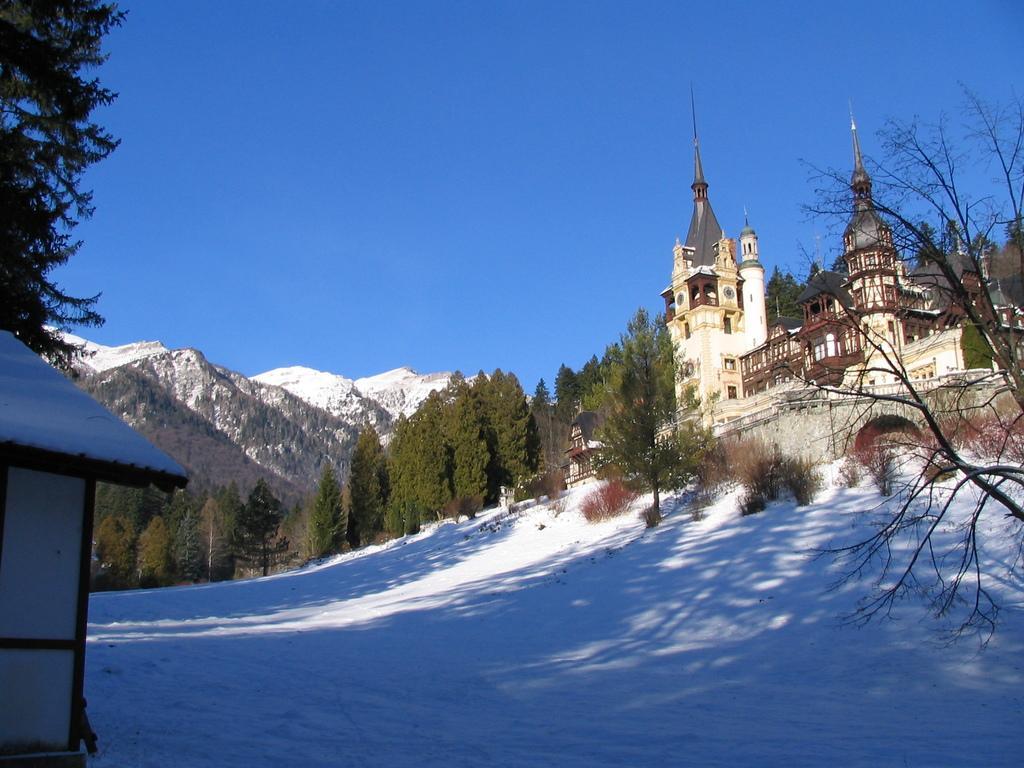Can you describe this image briefly? In this image we can see a building, mountains and some trees in front of mountains. In front of the building we can see snow on the ground and we can see a clear sky. 